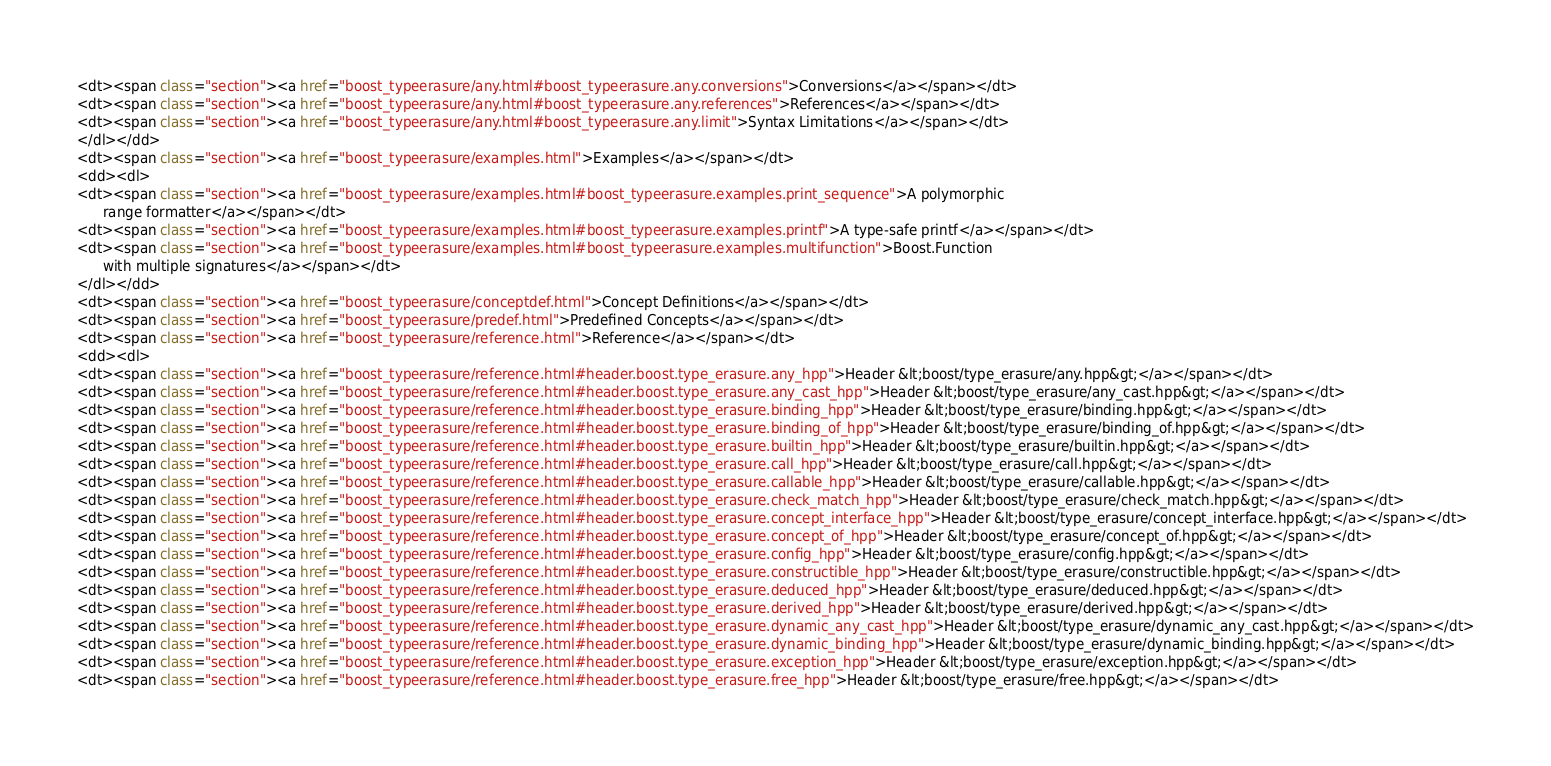Convert code to text. <code><loc_0><loc_0><loc_500><loc_500><_HTML_><dt><span class="section"><a href="boost_typeerasure/any.html#boost_typeerasure.any.conversions">Conversions</a></span></dt>
<dt><span class="section"><a href="boost_typeerasure/any.html#boost_typeerasure.any.references">References</a></span></dt>
<dt><span class="section"><a href="boost_typeerasure/any.html#boost_typeerasure.any.limit">Syntax Limitations</a></span></dt>
</dl></dd>
<dt><span class="section"><a href="boost_typeerasure/examples.html">Examples</a></span></dt>
<dd><dl>
<dt><span class="section"><a href="boost_typeerasure/examples.html#boost_typeerasure.examples.print_sequence">A polymorphic
      range formatter</a></span></dt>
<dt><span class="section"><a href="boost_typeerasure/examples.html#boost_typeerasure.examples.printf">A type-safe printf</a></span></dt>
<dt><span class="section"><a href="boost_typeerasure/examples.html#boost_typeerasure.examples.multifunction">Boost.Function
      with multiple signatures</a></span></dt>
</dl></dd>
<dt><span class="section"><a href="boost_typeerasure/conceptdef.html">Concept Definitions</a></span></dt>
<dt><span class="section"><a href="boost_typeerasure/predef.html">Predefined Concepts</a></span></dt>
<dt><span class="section"><a href="boost_typeerasure/reference.html">Reference</a></span></dt>
<dd><dl>
<dt><span class="section"><a href="boost_typeerasure/reference.html#header.boost.type_erasure.any_hpp">Header &lt;boost/type_erasure/any.hpp&gt;</a></span></dt>
<dt><span class="section"><a href="boost_typeerasure/reference.html#header.boost.type_erasure.any_cast_hpp">Header &lt;boost/type_erasure/any_cast.hpp&gt;</a></span></dt>
<dt><span class="section"><a href="boost_typeerasure/reference.html#header.boost.type_erasure.binding_hpp">Header &lt;boost/type_erasure/binding.hpp&gt;</a></span></dt>
<dt><span class="section"><a href="boost_typeerasure/reference.html#header.boost.type_erasure.binding_of_hpp">Header &lt;boost/type_erasure/binding_of.hpp&gt;</a></span></dt>
<dt><span class="section"><a href="boost_typeerasure/reference.html#header.boost.type_erasure.builtin_hpp">Header &lt;boost/type_erasure/builtin.hpp&gt;</a></span></dt>
<dt><span class="section"><a href="boost_typeerasure/reference.html#header.boost.type_erasure.call_hpp">Header &lt;boost/type_erasure/call.hpp&gt;</a></span></dt>
<dt><span class="section"><a href="boost_typeerasure/reference.html#header.boost.type_erasure.callable_hpp">Header &lt;boost/type_erasure/callable.hpp&gt;</a></span></dt>
<dt><span class="section"><a href="boost_typeerasure/reference.html#header.boost.type_erasure.check_match_hpp">Header &lt;boost/type_erasure/check_match.hpp&gt;</a></span></dt>
<dt><span class="section"><a href="boost_typeerasure/reference.html#header.boost.type_erasure.concept_interface_hpp">Header &lt;boost/type_erasure/concept_interface.hpp&gt;</a></span></dt>
<dt><span class="section"><a href="boost_typeerasure/reference.html#header.boost.type_erasure.concept_of_hpp">Header &lt;boost/type_erasure/concept_of.hpp&gt;</a></span></dt>
<dt><span class="section"><a href="boost_typeerasure/reference.html#header.boost.type_erasure.config_hpp">Header &lt;boost/type_erasure/config.hpp&gt;</a></span></dt>
<dt><span class="section"><a href="boost_typeerasure/reference.html#header.boost.type_erasure.constructible_hpp">Header &lt;boost/type_erasure/constructible.hpp&gt;</a></span></dt>
<dt><span class="section"><a href="boost_typeerasure/reference.html#header.boost.type_erasure.deduced_hpp">Header &lt;boost/type_erasure/deduced.hpp&gt;</a></span></dt>
<dt><span class="section"><a href="boost_typeerasure/reference.html#header.boost.type_erasure.derived_hpp">Header &lt;boost/type_erasure/derived.hpp&gt;</a></span></dt>
<dt><span class="section"><a href="boost_typeerasure/reference.html#header.boost.type_erasure.dynamic_any_cast_hpp">Header &lt;boost/type_erasure/dynamic_any_cast.hpp&gt;</a></span></dt>
<dt><span class="section"><a href="boost_typeerasure/reference.html#header.boost.type_erasure.dynamic_binding_hpp">Header &lt;boost/type_erasure/dynamic_binding.hpp&gt;</a></span></dt>
<dt><span class="section"><a href="boost_typeerasure/reference.html#header.boost.type_erasure.exception_hpp">Header &lt;boost/type_erasure/exception.hpp&gt;</a></span></dt>
<dt><span class="section"><a href="boost_typeerasure/reference.html#header.boost.type_erasure.free_hpp">Header &lt;boost/type_erasure/free.hpp&gt;</a></span></dt></code> 